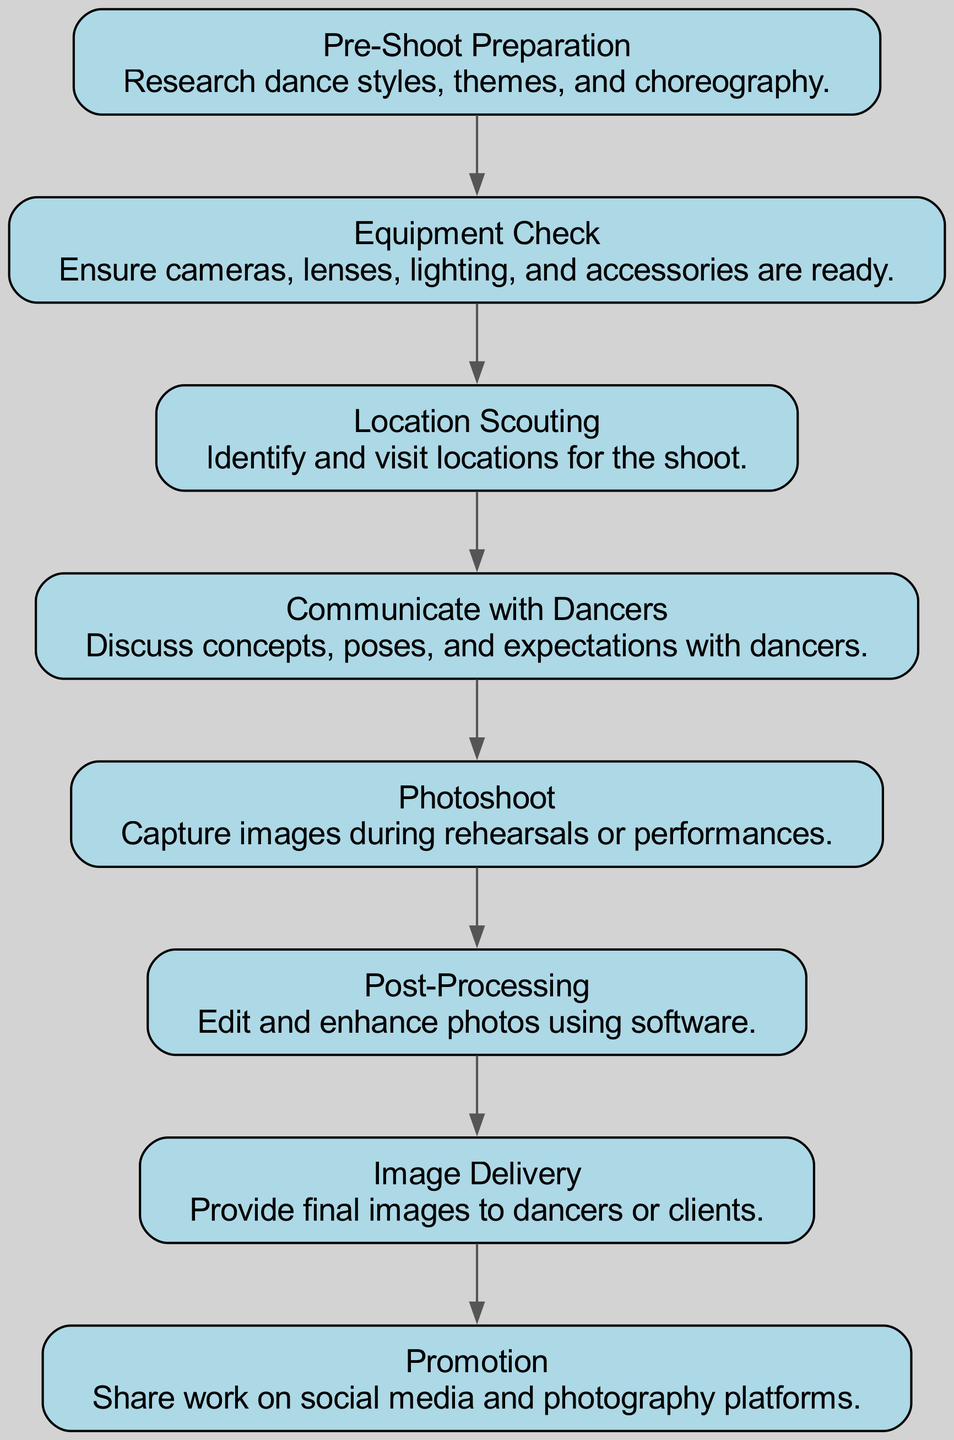What is the first step in the dance photography workflow? The first step is "Pre-Shoot Preparation," which is the initial stage where photographers research dance styles, themes, and choreography before starting the shoot.
Answer: Pre-Shoot Preparation How many nodes are present in the diagram? The diagram contains eight nodes, each representing a different step in the dance photography workflow.
Answer: Eight What step comes after "Equipment Check"? "Location Scouting" follows "Equipment Check," indicating that after ensuring all gear is ready, the photographer should identify and visit potential locations for the shoot.
Answer: Location Scouting Is there a direct edge from "Photoshoot" to "Image Delivery"? No, there is no direct edge connecting "Photoshoot" to "Image Delivery"; instead, "Photoshoot" leads to "Post-Processing," which then leads to "Image Delivery."
Answer: No What is the relationship between "Post-Processing" and "Promotion"? "Post-Processing" occurs before "Promotion"; the images must be edited and enhanced before they can be shared on social media and photography platforms. This shows a sequence in the workflow.
Answer: "Post-Processing" → "Promotion" What is the last step in the workflow? The last step in the workflow is "Promotion," where photographers share their work on social media and photography platforms after delivering the final images.
Answer: Promotion How many edges are in the graph? There are seven edges in the graph, representing the connections that show the workflow sequence from one step to the next.
Answer: Seven Which steps have a direct communication aspect involved? "Communicate with Dancers" is the only step that directly involves communication, focusing on discussing the concepts and expectations with the dancers.
Answer: Communicate with Dancers 